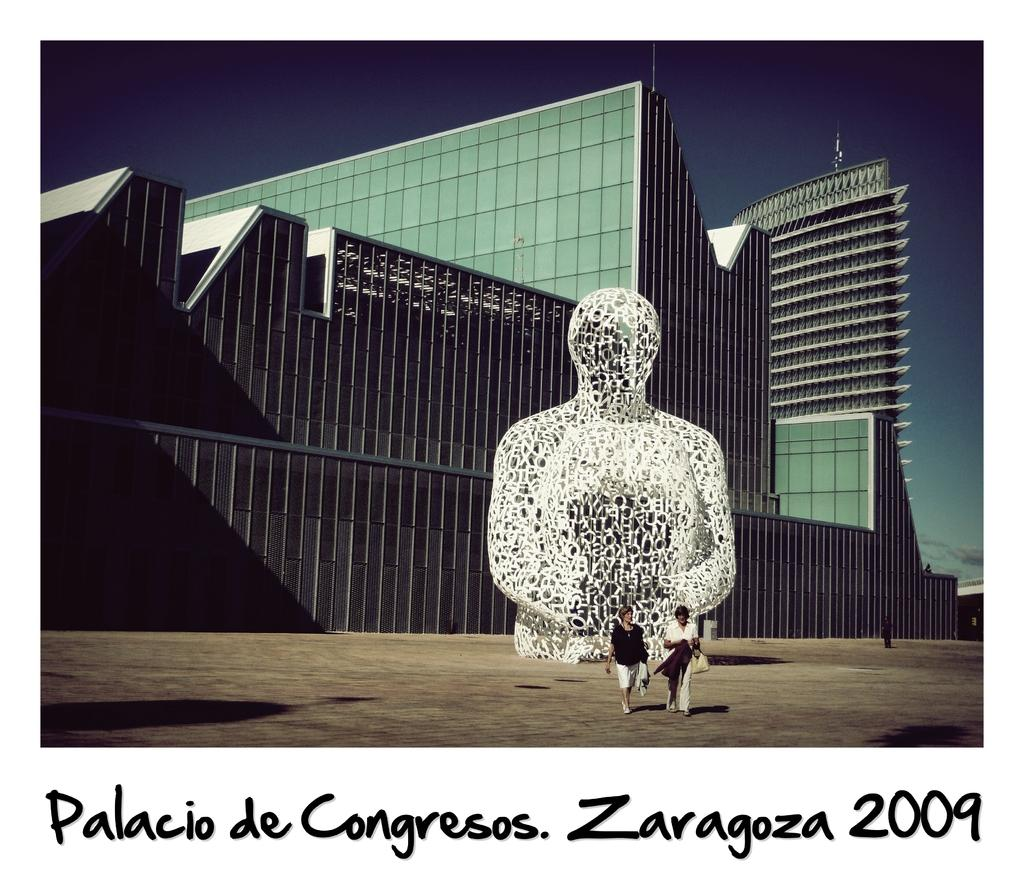<image>
Relay a brief, clear account of the picture shown. Two people walk in front of a huge wire statue of a figure on a postcard for a congress meeting in Zaragoza in 2009. 